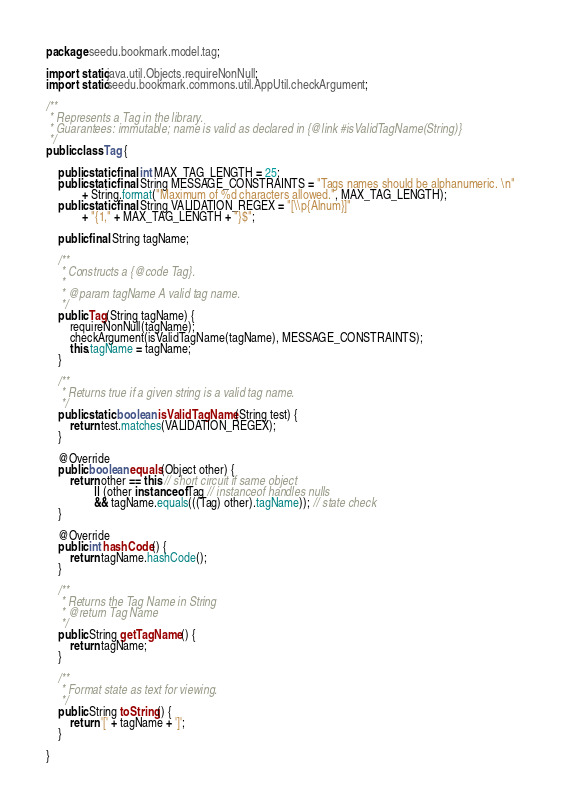Convert code to text. <code><loc_0><loc_0><loc_500><loc_500><_Java_>package seedu.bookmark.model.tag;

import static java.util.Objects.requireNonNull;
import static seedu.bookmark.commons.util.AppUtil.checkArgument;

/**
 * Represents a Tag in the library.
 * Guarantees: immutable; name is valid as declared in {@link #isValidTagName(String)}
 */
public class Tag {

    public static final int MAX_TAG_LENGTH = 25;
    public static final String MESSAGE_CONSTRAINTS = "Tags names should be alphanumeric. \n"
            + String.format("Maximum of %d characters allowed.", MAX_TAG_LENGTH);
    public static final String VALIDATION_REGEX = "[\\p{Alnum}]"
            + "{1," + MAX_TAG_LENGTH + "}$";

    public final String tagName;

    /**
     * Constructs a {@code Tag}.
     *
     * @param tagName A valid tag name.
     */
    public Tag(String tagName) {
        requireNonNull(tagName);
        checkArgument(isValidTagName(tagName), MESSAGE_CONSTRAINTS);
        this.tagName = tagName;
    }

    /**
     * Returns true if a given string is a valid tag name.
     */
    public static boolean isValidTagName(String test) {
        return test.matches(VALIDATION_REGEX);
    }

    @Override
    public boolean equals(Object other) {
        return other == this // short circuit if same object
                || (other instanceof Tag // instanceof handles nulls
                && tagName.equals(((Tag) other).tagName)); // state check
    }

    @Override
    public int hashCode() {
        return tagName.hashCode();
    }

    /**
     * Returns the Tag Name in String
     * @return Tag Name
     */
    public String getTagName() {
        return tagName;
    }

    /**
     * Format state as text for viewing.
     */
    public String toString() {
        return '[' + tagName + ']';
    }

}
</code> 